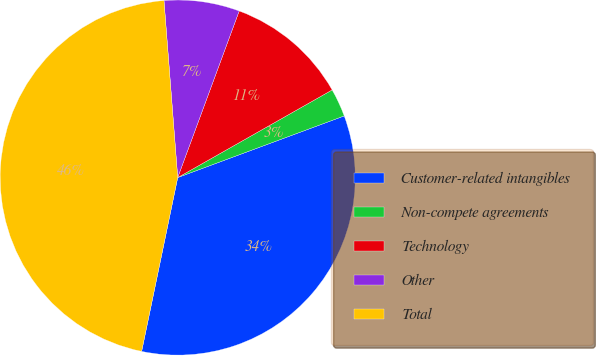<chart> <loc_0><loc_0><loc_500><loc_500><pie_chart><fcel>Customer-related intangibles<fcel>Non-compete agreements<fcel>Technology<fcel>Other<fcel>Total<nl><fcel>33.9%<fcel>2.57%<fcel>11.16%<fcel>6.86%<fcel>45.51%<nl></chart> 